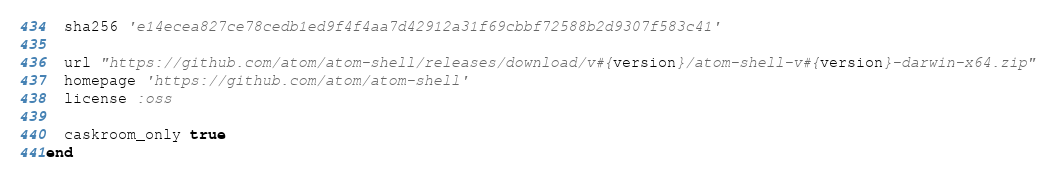Convert code to text. <code><loc_0><loc_0><loc_500><loc_500><_Ruby_>  sha256 'e14ecea827ce78cedb1ed9f4f4aa7d42912a31f69cbbf72588b2d9307f583c41'

  url "https://github.com/atom/atom-shell/releases/download/v#{version}/atom-shell-v#{version}-darwin-x64.zip"
  homepage 'https://github.com/atom/atom-shell'
  license :oss

  caskroom_only true
end
</code> 